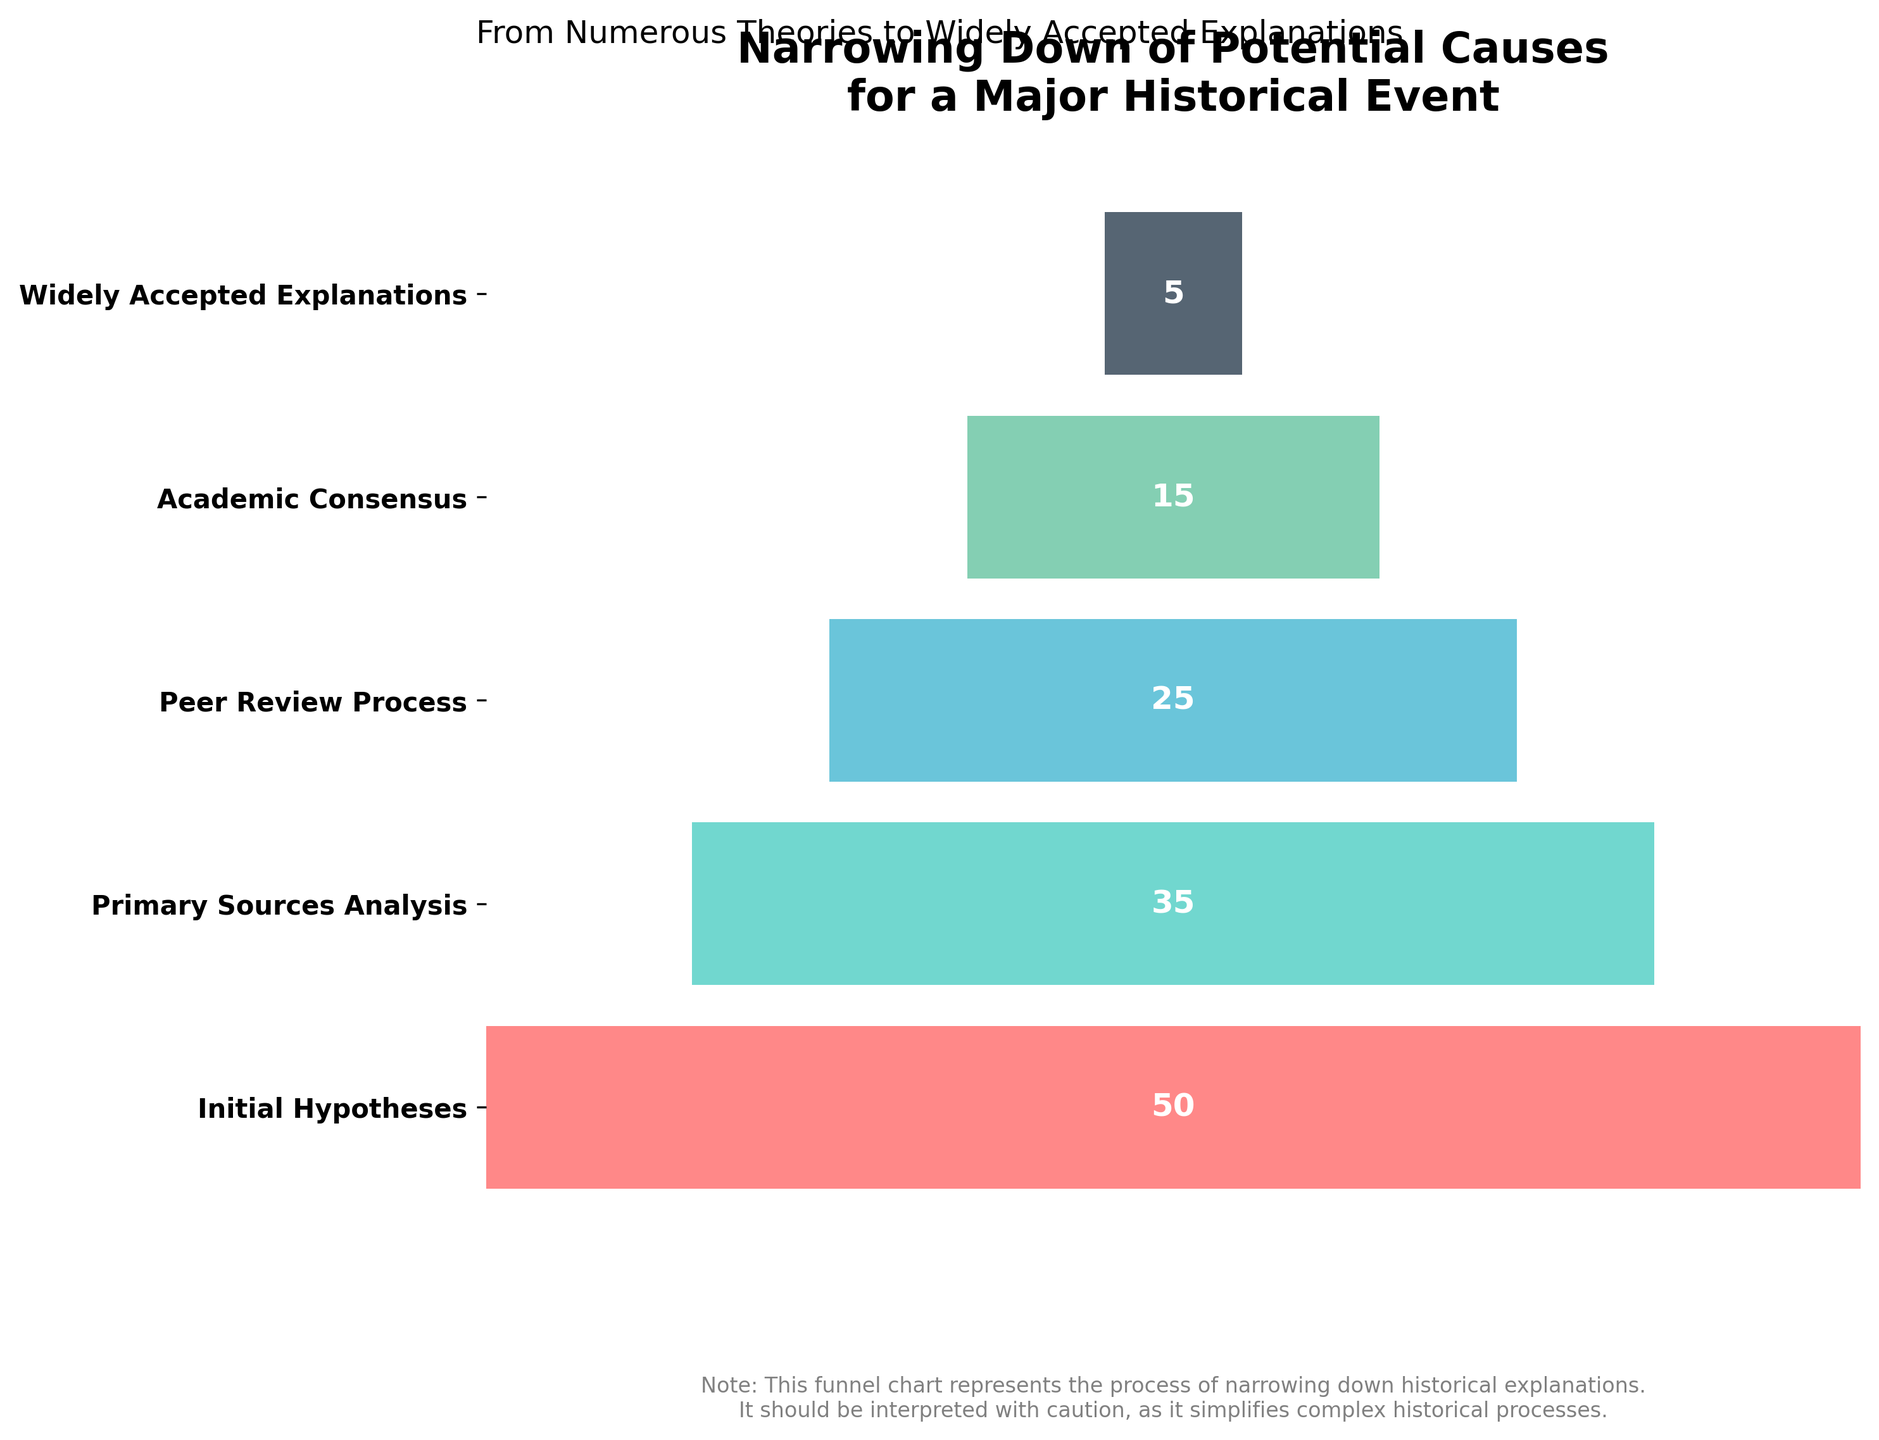What is the title of the chart? The title is located at the top of the chart. The text reads "Narrowing Down of Potential Causes for a Major Historical Event"
Answer: Narrowing Down of Potential Causes for a Major Historical Event How many stages are represented in the funnel chart? The funnel chart lists the stages on the y-axis. There are five stages described: "Initial Hypotheses," "Primary Sources Analysis," "Peer Review Process," "Academic Consensus," and "Widely Accepted Explanations."
Answer: 5 Which stage has the highest number of theories? The number of theories decreases as you move down the funnel. The topmost stage, "Initial Hypotheses," has the highest number, listed as 50 theories.
Answer: Initial Hypotheses How many theories are narrowed down between the "Initial Hypotheses" and the "Widely Accepted Explanations"? Subtract the number of theories in the "Widely Accepted Explanations" from the "Initial Hypotheses." That is, 50 - 5.
Answer: 45 What is the average number of theories across all stages? Add the number of theories for each stage: 50 + 35 + 25 + 15 + 5 = 130. Then, divide by the number of stages, 5. So, 130 / 5.
Answer: 26 What is the difference in the number of theories between the "Primary Sources Analysis" and the "Academic Consensus"? Subtract the number of theories in the "Academic Consensus" from those in the "Primary Sources Analysis": 35 - 15.
Answer: 20 Does the "Peer Review Process" stage have more or fewer theories compared to the "Academic Consensus" stage? Compare the number of theories in both stages: "Peer Review Process" has 25 theories, while "Academic Consensus" has 15 theories. 25 is more than 15.
Answer: More What colors are used in the funnel chart to represent different stages? The funnel chart uses a custom color palette. The colors from top to bottom stages are shades of red, green, blue, teal, and dark blue.
Answer: Red, Green, Blue, Teal, Dark Blue What is the purpose of the footnote in the funnel chart? The footnote, located at the bottom of the chart, provides additional information that the funnel chart simplifies complex historical processes and should be interpreted with caution.
Answer: It advises caution in interpreting the simplification of historical processes 